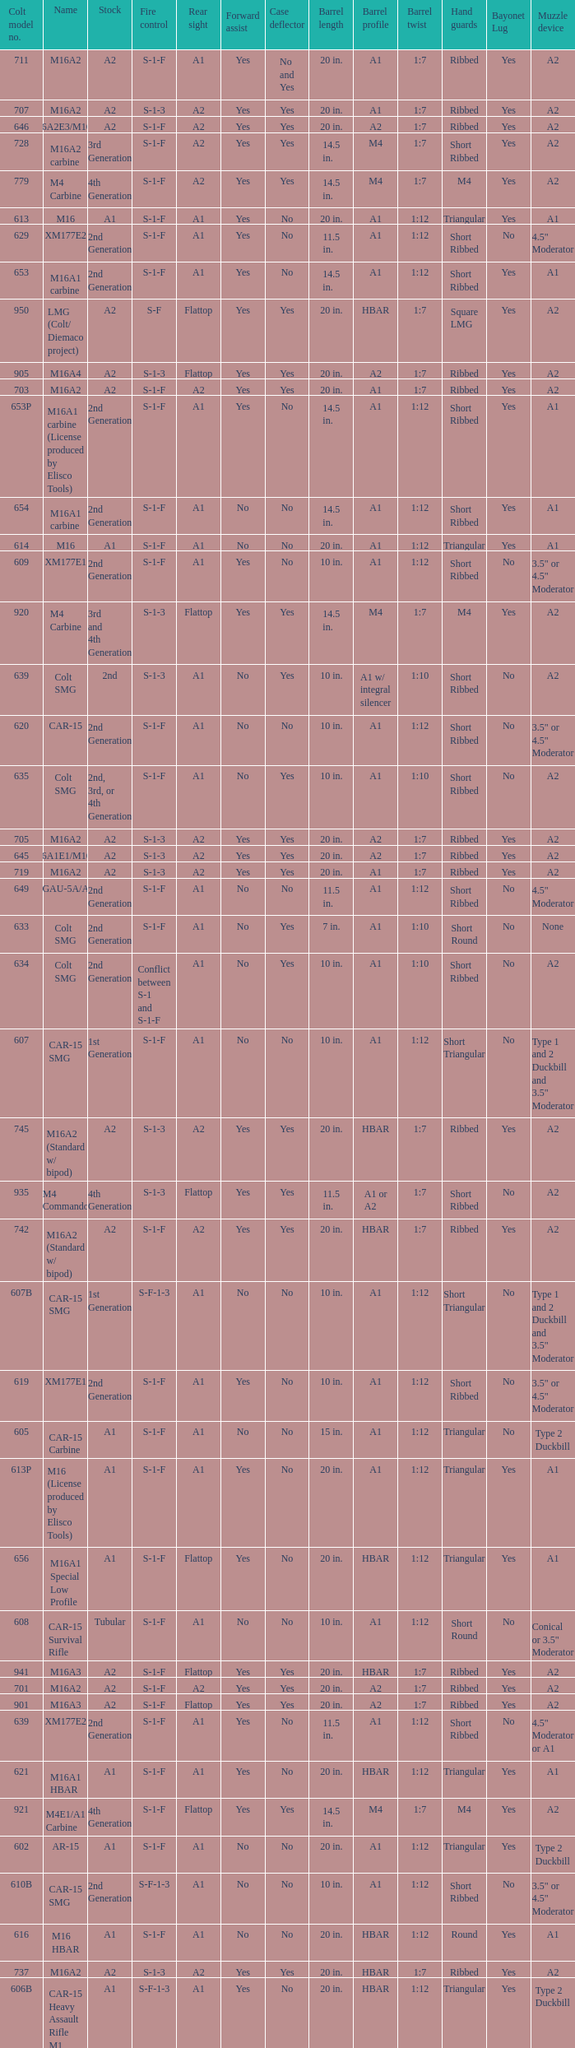What is the rear sight in the Cole model no. 735? A1 or A2. 